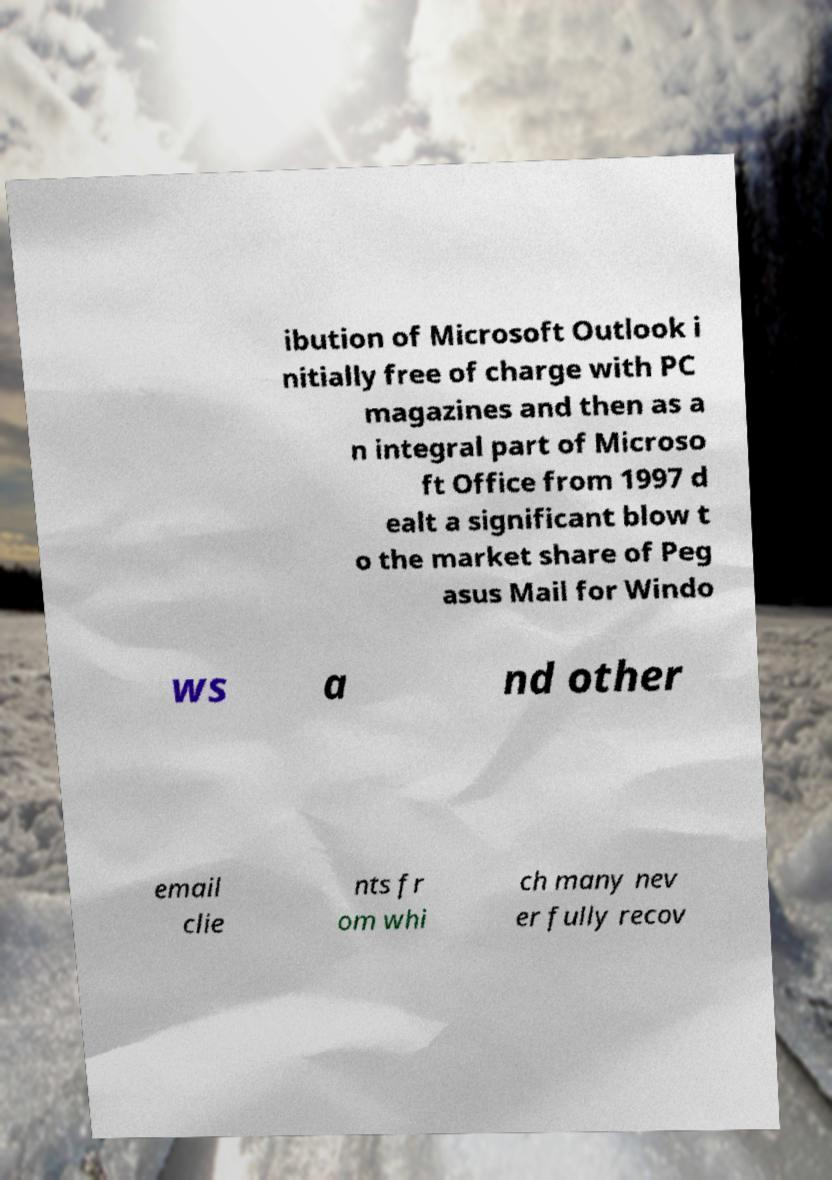Can you read and provide the text displayed in the image?This photo seems to have some interesting text. Can you extract and type it out for me? ibution of Microsoft Outlook i nitially free of charge with PC magazines and then as a n integral part of Microso ft Office from 1997 d ealt a significant blow t o the market share of Peg asus Mail for Windo ws a nd other email clie nts fr om whi ch many nev er fully recov 